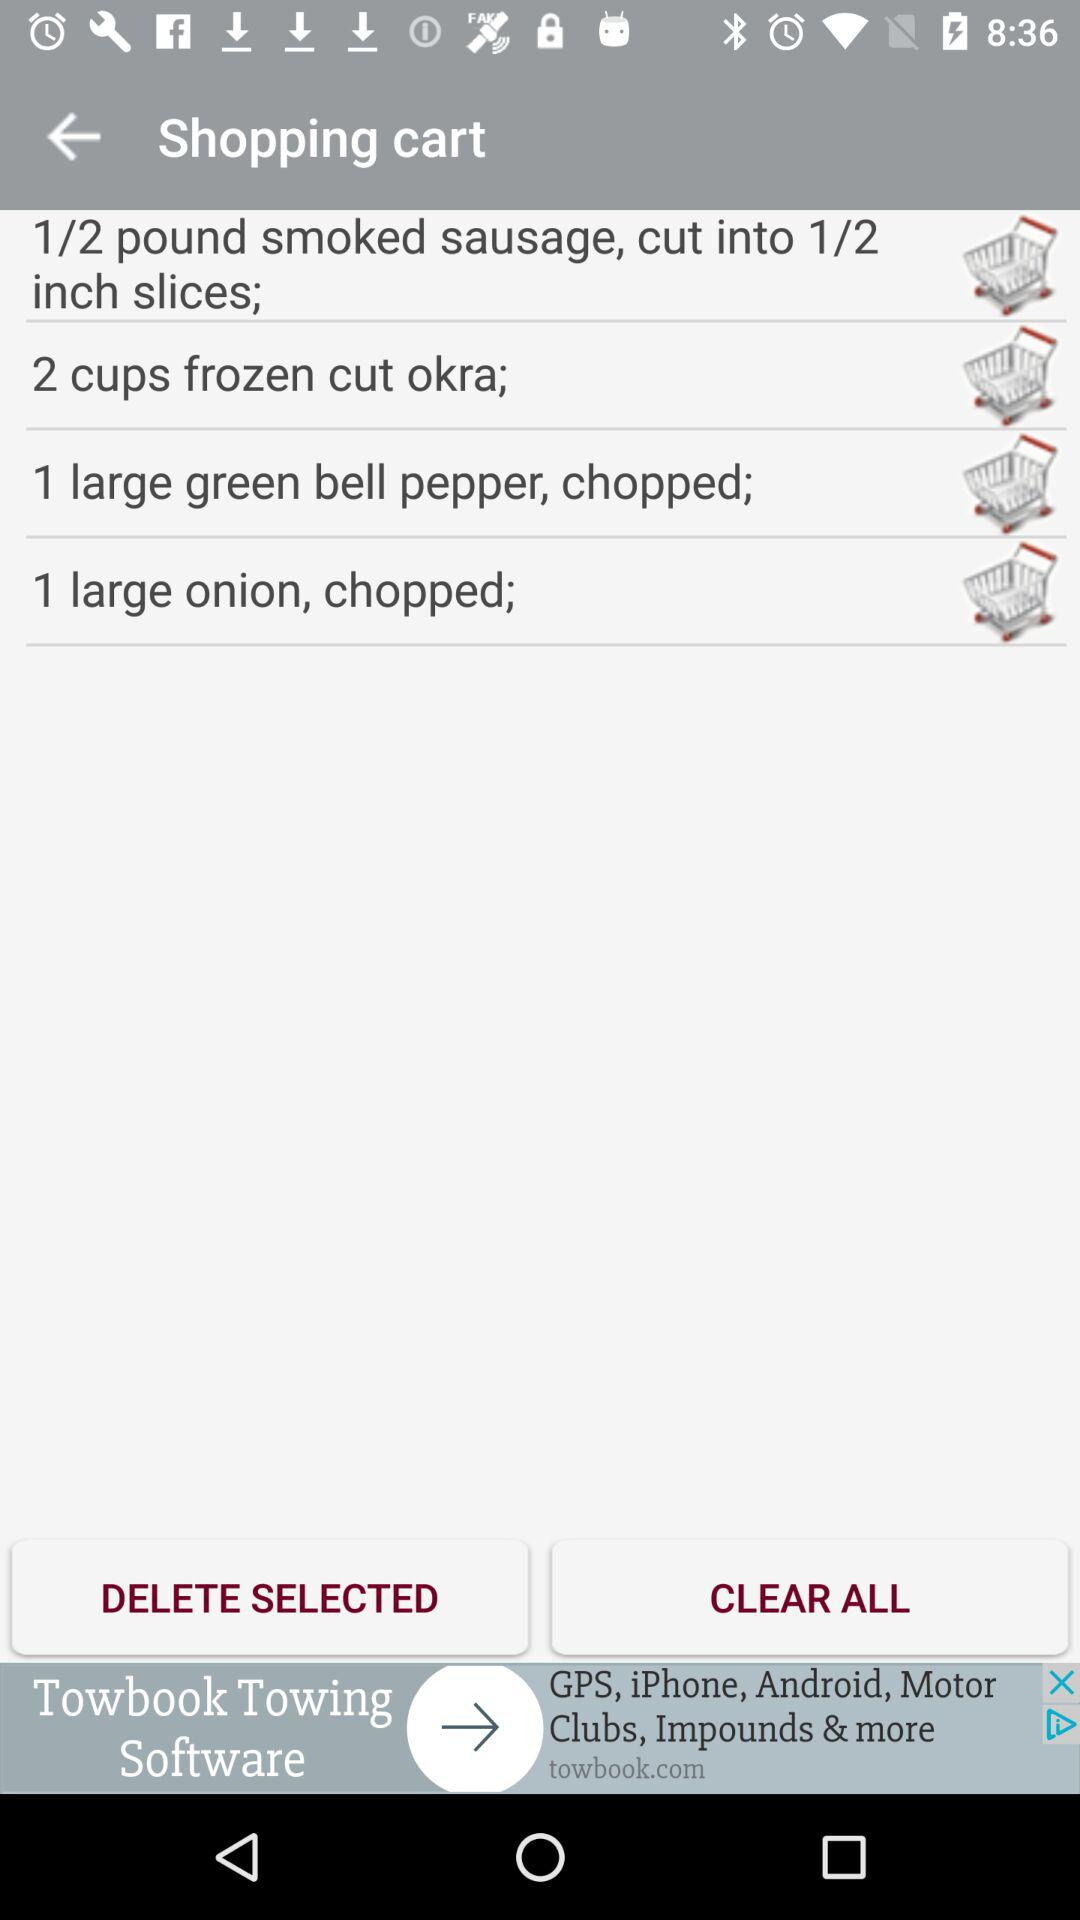What is the count of smoked sausage?
When the provided information is insufficient, respond with <no answer>. <no answer> 